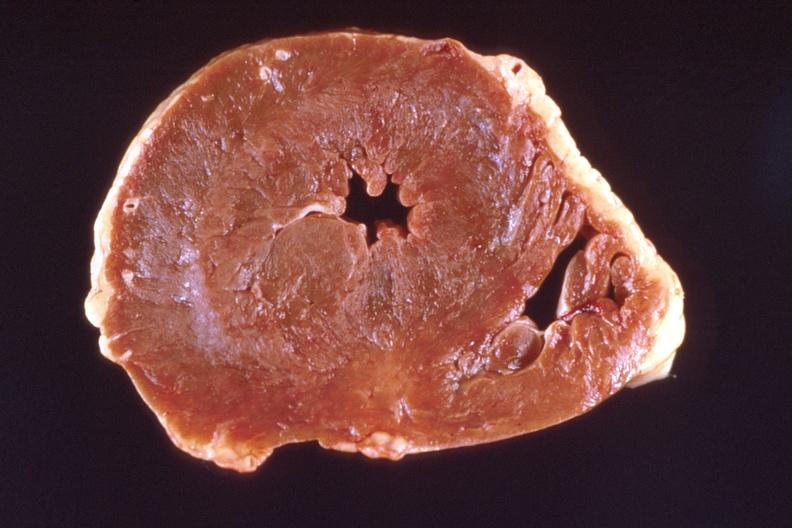s stillborn cord around neck present?
Answer the question using a single word or phrase. No 